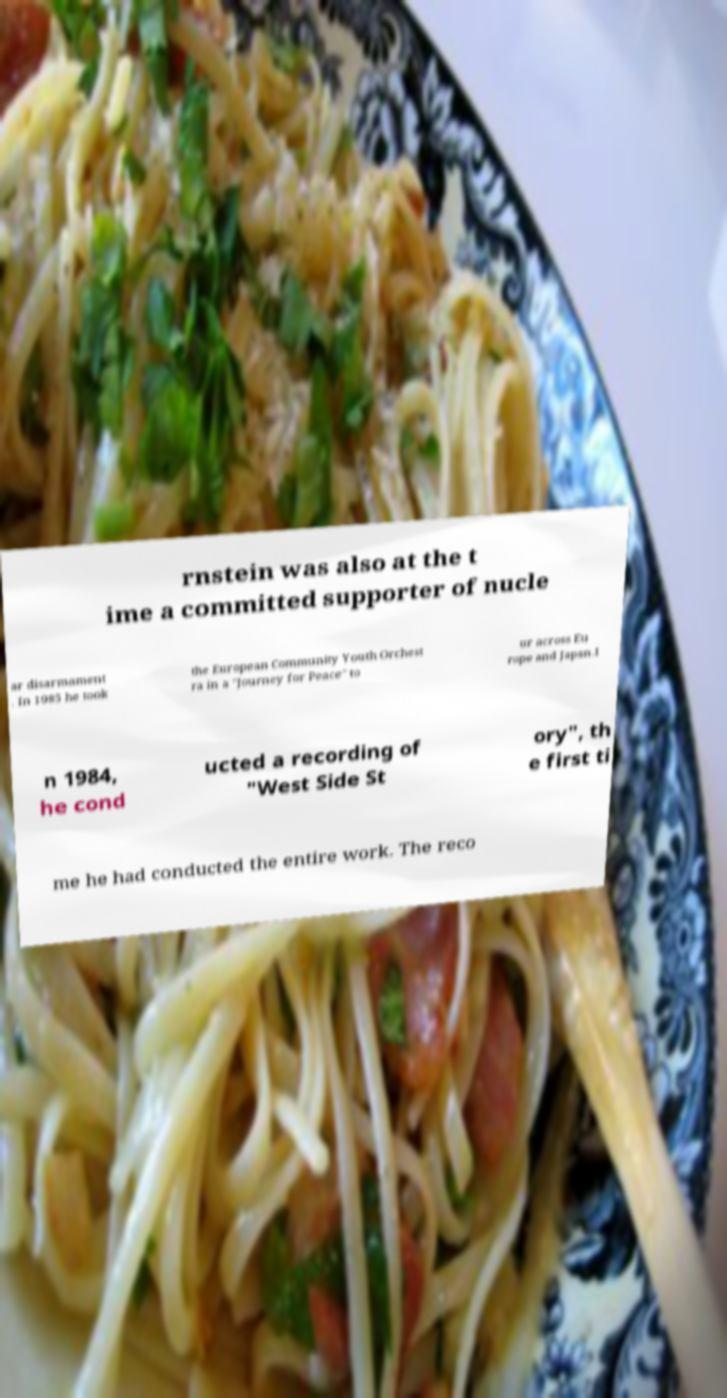Could you assist in decoding the text presented in this image and type it out clearly? rnstein was also at the t ime a committed supporter of nucle ar disarmament . In 1985 he took the European Community Youth Orchest ra in a "Journey for Peace" to ur across Eu rope and Japan.I n 1984, he cond ucted a recording of "West Side St ory", th e first ti me he had conducted the entire work. The reco 